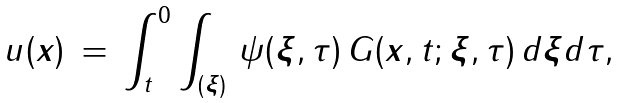Convert formula to latex. <formula><loc_0><loc_0><loc_500><loc_500>u ( { \boldsymbol x } ) \, = \, \int ^ { 0 } _ { t } \int _ { ( { \boldsymbol \xi } ) } \, \psi ( { \boldsymbol \xi } , \tau ) \, G ( { \boldsymbol x } , t ; { \boldsymbol \xi } , \tau ) \, d { \boldsymbol \xi } d \tau ,</formula> 